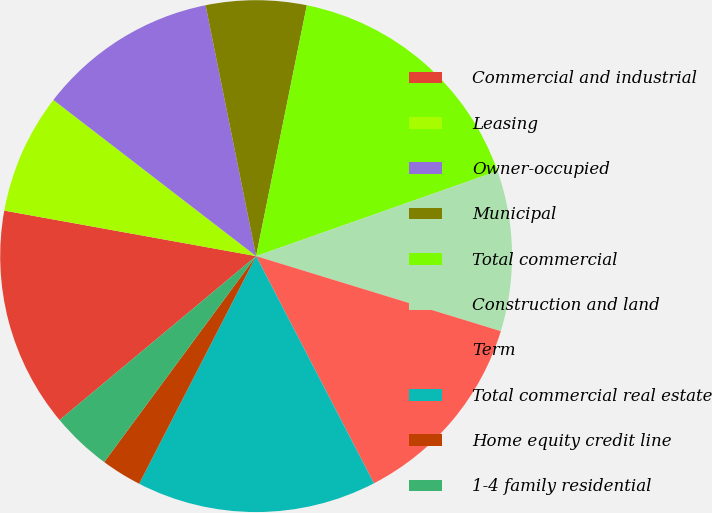Convert chart. <chart><loc_0><loc_0><loc_500><loc_500><pie_chart><fcel>Commercial and industrial<fcel>Leasing<fcel>Owner-occupied<fcel>Municipal<fcel>Total commercial<fcel>Construction and land<fcel>Term<fcel>Total commercial real estate<fcel>Home equity credit line<fcel>1-4 family residential<nl><fcel>13.91%<fcel>7.6%<fcel>11.39%<fcel>6.34%<fcel>16.43%<fcel>10.13%<fcel>12.65%<fcel>15.17%<fcel>2.56%<fcel>3.82%<nl></chart> 